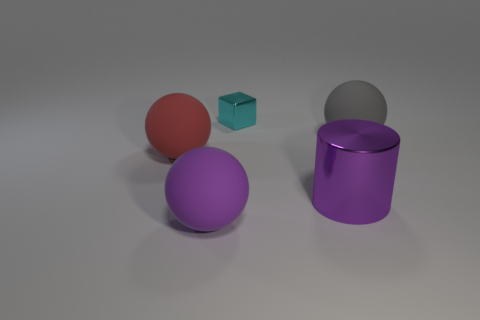Can you describe the colors and shapes visible in the image? Certainly! The image features a purple cylinder, a red sphere, a smaller violet sphere, a tiny blue cube, and a large silver cylinder that appears slightly transparent. Each object has a distinct color and is rendered with a different finish - some glossy and reflective, others matte. 